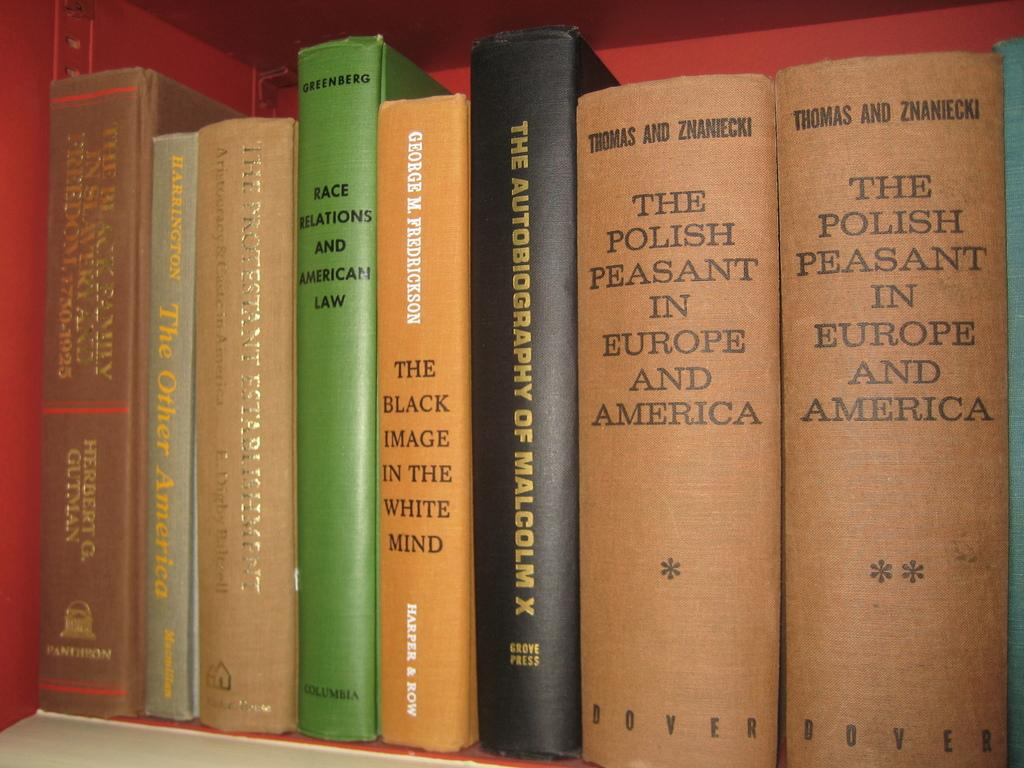<image>
Offer a succinct explanation of the picture presented. A book titled The Polish Peasant in Europe and America on a book shelf. 